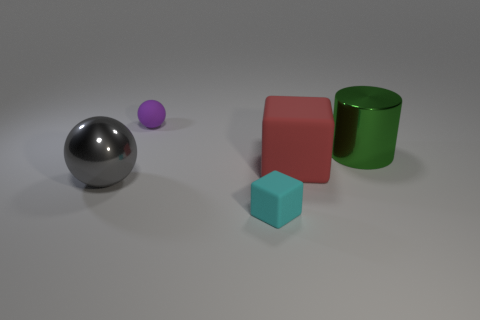What shape is the big thing behind the red matte object? cylinder 